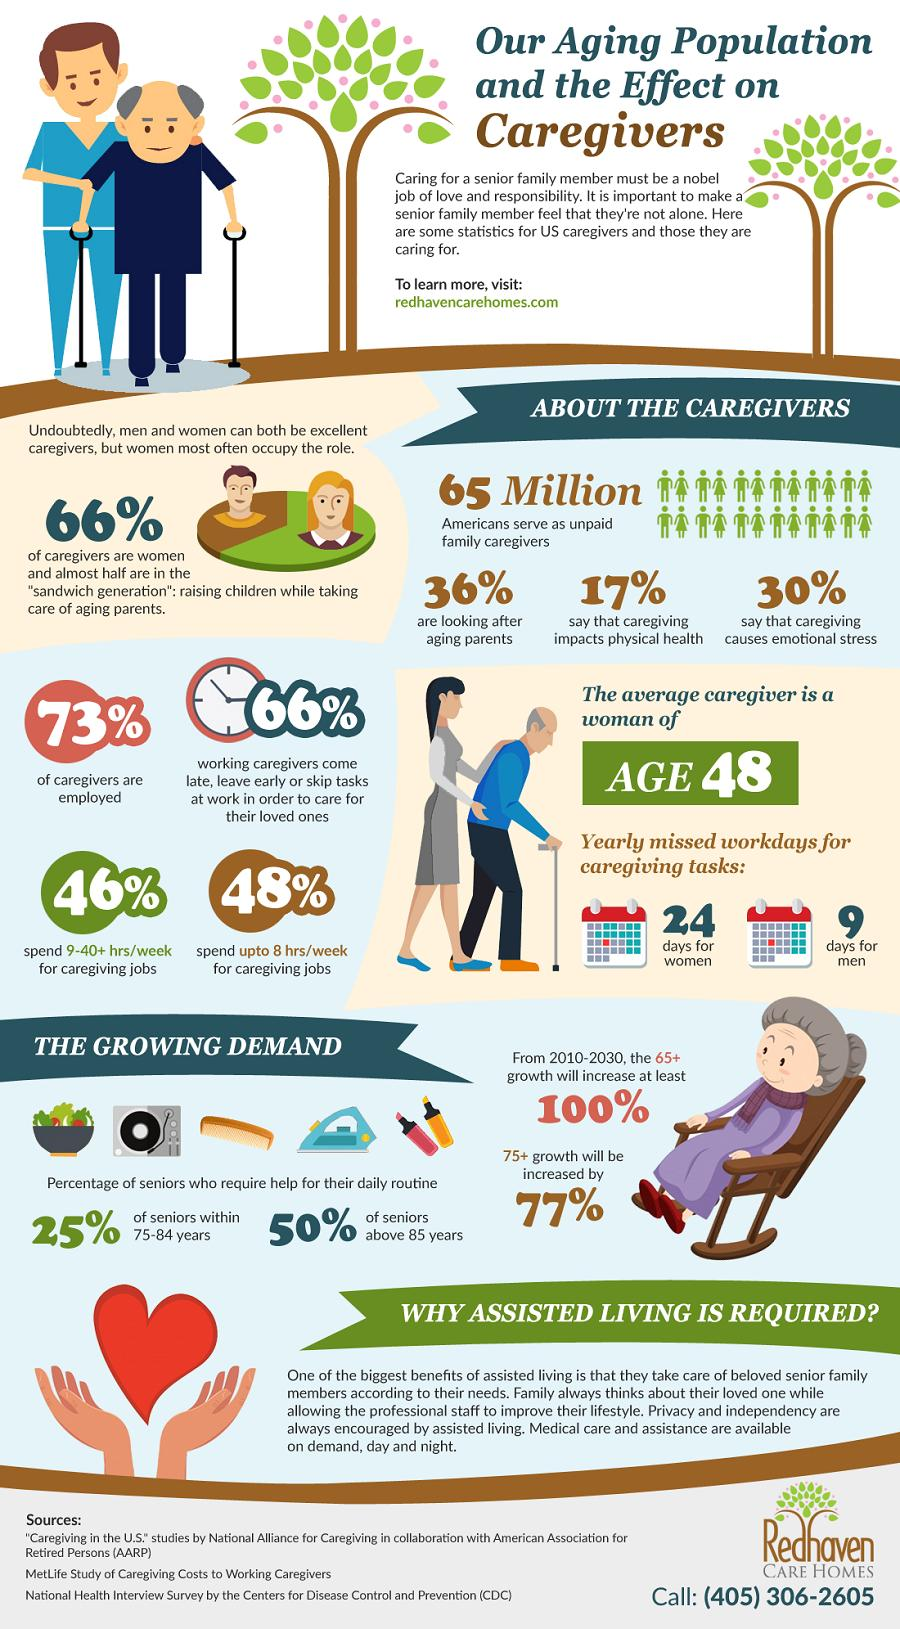Give some essential details in this illustration. According to a recent study, only 66% of caregivers are women, with the remaining 34% being men. According to recent statistics, 36% of caregivers are looking after aging parents. Approximately 27% of caregivers are not employed, suggesting that a significant portion of caregiving responsibilities are being shouldered by individuals who are also juggling work and other responsibilities. According to a survey, 46% of caregivers spend 9 to 40 or more hours per week on caregiving jobs. 